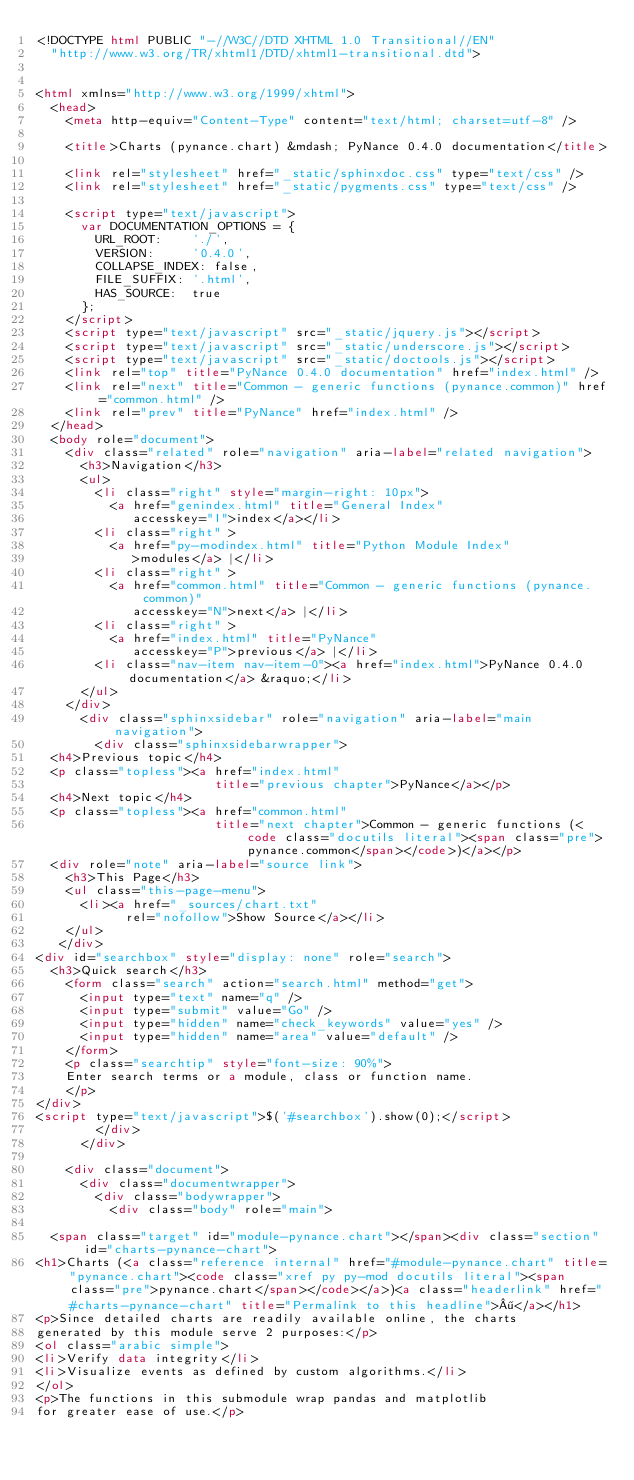Convert code to text. <code><loc_0><loc_0><loc_500><loc_500><_HTML_><!DOCTYPE html PUBLIC "-//W3C//DTD XHTML 1.0 Transitional//EN"
  "http://www.w3.org/TR/xhtml1/DTD/xhtml1-transitional.dtd">


<html xmlns="http://www.w3.org/1999/xhtml">
  <head>
    <meta http-equiv="Content-Type" content="text/html; charset=utf-8" />
    
    <title>Charts (pynance.chart) &mdash; PyNance 0.4.0 documentation</title>
    
    <link rel="stylesheet" href="_static/sphinxdoc.css" type="text/css" />
    <link rel="stylesheet" href="_static/pygments.css" type="text/css" />
    
    <script type="text/javascript">
      var DOCUMENTATION_OPTIONS = {
        URL_ROOT:    './',
        VERSION:     '0.4.0',
        COLLAPSE_INDEX: false,
        FILE_SUFFIX: '.html',
        HAS_SOURCE:  true
      };
    </script>
    <script type="text/javascript" src="_static/jquery.js"></script>
    <script type="text/javascript" src="_static/underscore.js"></script>
    <script type="text/javascript" src="_static/doctools.js"></script>
    <link rel="top" title="PyNance 0.4.0 documentation" href="index.html" />
    <link rel="next" title="Common - generic functions (pynance.common)" href="common.html" />
    <link rel="prev" title="PyNance" href="index.html" /> 
  </head>
  <body role="document">
    <div class="related" role="navigation" aria-label="related navigation">
      <h3>Navigation</h3>
      <ul>
        <li class="right" style="margin-right: 10px">
          <a href="genindex.html" title="General Index"
             accesskey="I">index</a></li>
        <li class="right" >
          <a href="py-modindex.html" title="Python Module Index"
             >modules</a> |</li>
        <li class="right" >
          <a href="common.html" title="Common - generic functions (pynance.common)"
             accesskey="N">next</a> |</li>
        <li class="right" >
          <a href="index.html" title="PyNance"
             accesskey="P">previous</a> |</li>
        <li class="nav-item nav-item-0"><a href="index.html">PyNance 0.4.0 documentation</a> &raquo;</li> 
      </ul>
    </div>
      <div class="sphinxsidebar" role="navigation" aria-label="main navigation">
        <div class="sphinxsidebarwrapper">
  <h4>Previous topic</h4>
  <p class="topless"><a href="index.html"
                        title="previous chapter">PyNance</a></p>
  <h4>Next topic</h4>
  <p class="topless"><a href="common.html"
                        title="next chapter">Common - generic functions (<code class="docutils literal"><span class="pre">pynance.common</span></code>)</a></p>
  <div role="note" aria-label="source link">
    <h3>This Page</h3>
    <ul class="this-page-menu">
      <li><a href="_sources/chart.txt"
            rel="nofollow">Show Source</a></li>
    </ul>
   </div>
<div id="searchbox" style="display: none" role="search">
  <h3>Quick search</h3>
    <form class="search" action="search.html" method="get">
      <input type="text" name="q" />
      <input type="submit" value="Go" />
      <input type="hidden" name="check_keywords" value="yes" />
      <input type="hidden" name="area" value="default" />
    </form>
    <p class="searchtip" style="font-size: 90%">
    Enter search terms or a module, class or function name.
    </p>
</div>
<script type="text/javascript">$('#searchbox').show(0);</script>
        </div>
      </div>

    <div class="document">
      <div class="documentwrapper">
        <div class="bodywrapper">
          <div class="body" role="main">
            
  <span class="target" id="module-pynance.chart"></span><div class="section" id="charts-pynance-chart">
<h1>Charts (<a class="reference internal" href="#module-pynance.chart" title="pynance.chart"><code class="xref py py-mod docutils literal"><span class="pre">pynance.chart</span></code></a>)<a class="headerlink" href="#charts-pynance-chart" title="Permalink to this headline">¶</a></h1>
<p>Since detailed charts are readily available online, the charts
generated by this module serve 2 purposes:</p>
<ol class="arabic simple">
<li>Verify data integrity</li>
<li>Visualize events as defined by custom algorithms.</li>
</ol>
<p>The functions in this submodule wrap pandas and matplotlib
for greater ease of use.</p></code> 